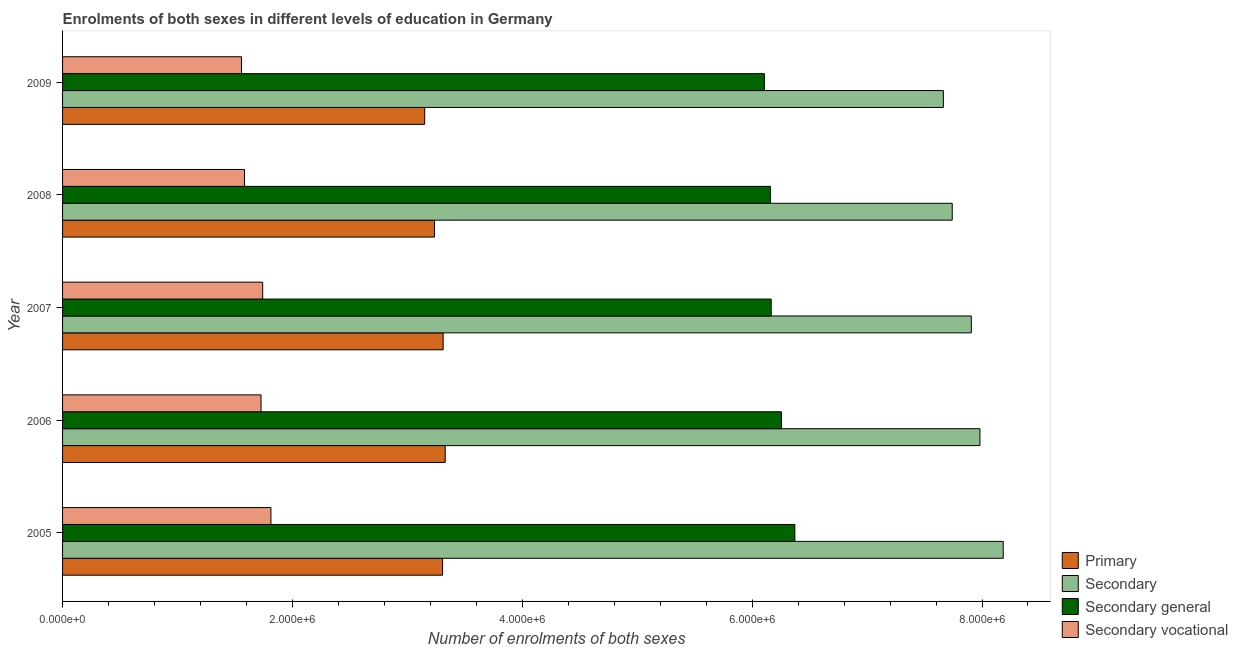Are the number of bars per tick equal to the number of legend labels?
Offer a terse response. Yes. How many bars are there on the 5th tick from the bottom?
Make the answer very short. 4. What is the label of the 5th group of bars from the top?
Make the answer very short. 2005. What is the number of enrolments in primary education in 2008?
Give a very brief answer. 3.24e+06. Across all years, what is the maximum number of enrolments in secondary education?
Your response must be concise. 8.18e+06. Across all years, what is the minimum number of enrolments in secondary vocational education?
Your answer should be very brief. 1.56e+06. What is the total number of enrolments in secondary education in the graph?
Your answer should be compact. 3.95e+07. What is the difference between the number of enrolments in primary education in 2008 and that in 2009?
Provide a succinct answer. 8.53e+04. What is the difference between the number of enrolments in secondary general education in 2007 and the number of enrolments in secondary education in 2005?
Provide a succinct answer. -2.02e+06. What is the average number of enrolments in secondary education per year?
Offer a very short reply. 7.90e+06. In the year 2009, what is the difference between the number of enrolments in secondary education and number of enrolments in secondary vocational education?
Provide a succinct answer. 6.11e+06. In how many years, is the number of enrolments in primary education greater than 8000000 ?
Offer a terse response. 0. What is the difference between the highest and the second highest number of enrolments in primary education?
Provide a short and direct response. 1.81e+04. What is the difference between the highest and the lowest number of enrolments in secondary vocational education?
Give a very brief answer. 2.56e+05. In how many years, is the number of enrolments in secondary general education greater than the average number of enrolments in secondary general education taken over all years?
Offer a terse response. 2. Is the sum of the number of enrolments in secondary education in 2005 and 2008 greater than the maximum number of enrolments in secondary general education across all years?
Give a very brief answer. Yes. What does the 2nd bar from the top in 2008 represents?
Provide a succinct answer. Secondary general. What does the 2nd bar from the bottom in 2005 represents?
Offer a very short reply. Secondary. Are the values on the major ticks of X-axis written in scientific E-notation?
Make the answer very short. Yes. How many legend labels are there?
Offer a very short reply. 4. What is the title of the graph?
Provide a short and direct response. Enrolments of both sexes in different levels of education in Germany. What is the label or title of the X-axis?
Give a very brief answer. Number of enrolments of both sexes. What is the label or title of the Y-axis?
Provide a succinct answer. Year. What is the Number of enrolments of both sexes of Primary in 2005?
Make the answer very short. 3.31e+06. What is the Number of enrolments of both sexes in Secondary in 2005?
Make the answer very short. 8.18e+06. What is the Number of enrolments of both sexes of Secondary general in 2005?
Keep it short and to the point. 6.37e+06. What is the Number of enrolments of both sexes of Secondary vocational in 2005?
Give a very brief answer. 1.81e+06. What is the Number of enrolments of both sexes in Primary in 2006?
Your answer should be very brief. 3.33e+06. What is the Number of enrolments of both sexes in Secondary in 2006?
Your response must be concise. 7.98e+06. What is the Number of enrolments of both sexes of Secondary general in 2006?
Provide a succinct answer. 6.26e+06. What is the Number of enrolments of both sexes of Secondary vocational in 2006?
Your answer should be compact. 1.73e+06. What is the Number of enrolments of both sexes in Primary in 2007?
Offer a very short reply. 3.31e+06. What is the Number of enrolments of both sexes of Secondary in 2007?
Your answer should be very brief. 7.91e+06. What is the Number of enrolments of both sexes of Secondary general in 2007?
Provide a short and direct response. 6.17e+06. What is the Number of enrolments of both sexes in Secondary vocational in 2007?
Your answer should be very brief. 1.74e+06. What is the Number of enrolments of both sexes in Primary in 2008?
Give a very brief answer. 3.24e+06. What is the Number of enrolments of both sexes in Secondary in 2008?
Provide a short and direct response. 7.74e+06. What is the Number of enrolments of both sexes in Secondary general in 2008?
Offer a terse response. 6.16e+06. What is the Number of enrolments of both sexes in Secondary vocational in 2008?
Your answer should be very brief. 1.58e+06. What is the Number of enrolments of both sexes in Primary in 2009?
Give a very brief answer. 3.15e+06. What is the Number of enrolments of both sexes in Secondary in 2009?
Your answer should be compact. 7.66e+06. What is the Number of enrolments of both sexes in Secondary general in 2009?
Keep it short and to the point. 6.11e+06. What is the Number of enrolments of both sexes of Secondary vocational in 2009?
Make the answer very short. 1.56e+06. Across all years, what is the maximum Number of enrolments of both sexes in Primary?
Provide a short and direct response. 3.33e+06. Across all years, what is the maximum Number of enrolments of both sexes of Secondary?
Ensure brevity in your answer.  8.18e+06. Across all years, what is the maximum Number of enrolments of both sexes of Secondary general?
Your answer should be compact. 6.37e+06. Across all years, what is the maximum Number of enrolments of both sexes of Secondary vocational?
Make the answer very short. 1.81e+06. Across all years, what is the minimum Number of enrolments of both sexes of Primary?
Offer a very short reply. 3.15e+06. Across all years, what is the minimum Number of enrolments of both sexes in Secondary?
Ensure brevity in your answer.  7.66e+06. Across all years, what is the minimum Number of enrolments of both sexes of Secondary general?
Your response must be concise. 6.11e+06. Across all years, what is the minimum Number of enrolments of both sexes in Secondary vocational?
Make the answer very short. 1.56e+06. What is the total Number of enrolments of both sexes in Primary in the graph?
Offer a terse response. 1.63e+07. What is the total Number of enrolments of both sexes of Secondary in the graph?
Your response must be concise. 3.95e+07. What is the total Number of enrolments of both sexes in Secondary general in the graph?
Your answer should be very brief. 3.11e+07. What is the total Number of enrolments of both sexes of Secondary vocational in the graph?
Keep it short and to the point. 8.42e+06. What is the difference between the Number of enrolments of both sexes of Primary in 2005 and that in 2006?
Make the answer very short. -2.32e+04. What is the difference between the Number of enrolments of both sexes in Secondary in 2005 and that in 2006?
Offer a very short reply. 2.03e+05. What is the difference between the Number of enrolments of both sexes in Secondary general in 2005 and that in 2006?
Offer a terse response. 1.16e+05. What is the difference between the Number of enrolments of both sexes in Secondary vocational in 2005 and that in 2006?
Provide a short and direct response. 8.63e+04. What is the difference between the Number of enrolments of both sexes in Primary in 2005 and that in 2007?
Your answer should be very brief. -5149. What is the difference between the Number of enrolments of both sexes in Secondary in 2005 and that in 2007?
Provide a short and direct response. 2.77e+05. What is the difference between the Number of enrolments of both sexes in Secondary general in 2005 and that in 2007?
Keep it short and to the point. 2.06e+05. What is the difference between the Number of enrolments of both sexes of Secondary vocational in 2005 and that in 2007?
Offer a very short reply. 7.17e+04. What is the difference between the Number of enrolments of both sexes of Primary in 2005 and that in 2008?
Offer a very short reply. 7.00e+04. What is the difference between the Number of enrolments of both sexes in Secondary in 2005 and that in 2008?
Offer a very short reply. 4.44e+05. What is the difference between the Number of enrolments of both sexes of Secondary general in 2005 and that in 2008?
Ensure brevity in your answer.  2.13e+05. What is the difference between the Number of enrolments of both sexes in Secondary vocational in 2005 and that in 2008?
Provide a short and direct response. 2.30e+05. What is the difference between the Number of enrolments of both sexes of Primary in 2005 and that in 2009?
Provide a short and direct response. 1.55e+05. What is the difference between the Number of enrolments of both sexes in Secondary in 2005 and that in 2009?
Ensure brevity in your answer.  5.21e+05. What is the difference between the Number of enrolments of both sexes of Secondary general in 2005 and that in 2009?
Your answer should be very brief. 2.65e+05. What is the difference between the Number of enrolments of both sexes of Secondary vocational in 2005 and that in 2009?
Your response must be concise. 2.56e+05. What is the difference between the Number of enrolments of both sexes in Primary in 2006 and that in 2007?
Keep it short and to the point. 1.81e+04. What is the difference between the Number of enrolments of both sexes of Secondary in 2006 and that in 2007?
Your answer should be compact. 7.47e+04. What is the difference between the Number of enrolments of both sexes in Secondary general in 2006 and that in 2007?
Provide a short and direct response. 8.93e+04. What is the difference between the Number of enrolments of both sexes of Secondary vocational in 2006 and that in 2007?
Your answer should be compact. -1.46e+04. What is the difference between the Number of enrolments of both sexes of Primary in 2006 and that in 2008?
Provide a succinct answer. 9.32e+04. What is the difference between the Number of enrolments of both sexes of Secondary in 2006 and that in 2008?
Provide a succinct answer. 2.41e+05. What is the difference between the Number of enrolments of both sexes in Secondary general in 2006 and that in 2008?
Provide a short and direct response. 9.69e+04. What is the difference between the Number of enrolments of both sexes in Secondary vocational in 2006 and that in 2008?
Keep it short and to the point. 1.44e+05. What is the difference between the Number of enrolments of both sexes of Primary in 2006 and that in 2009?
Keep it short and to the point. 1.79e+05. What is the difference between the Number of enrolments of both sexes of Secondary in 2006 and that in 2009?
Offer a terse response. 3.18e+05. What is the difference between the Number of enrolments of both sexes of Secondary general in 2006 and that in 2009?
Your answer should be compact. 1.49e+05. What is the difference between the Number of enrolments of both sexes in Secondary vocational in 2006 and that in 2009?
Offer a very short reply. 1.70e+05. What is the difference between the Number of enrolments of both sexes in Primary in 2007 and that in 2008?
Offer a terse response. 7.51e+04. What is the difference between the Number of enrolments of both sexes of Secondary in 2007 and that in 2008?
Provide a short and direct response. 1.66e+05. What is the difference between the Number of enrolments of both sexes in Secondary general in 2007 and that in 2008?
Provide a succinct answer. 7606. What is the difference between the Number of enrolments of both sexes of Secondary vocational in 2007 and that in 2008?
Provide a short and direct response. 1.59e+05. What is the difference between the Number of enrolments of both sexes of Primary in 2007 and that in 2009?
Give a very brief answer. 1.60e+05. What is the difference between the Number of enrolments of both sexes of Secondary in 2007 and that in 2009?
Give a very brief answer. 2.43e+05. What is the difference between the Number of enrolments of both sexes in Secondary general in 2007 and that in 2009?
Give a very brief answer. 5.93e+04. What is the difference between the Number of enrolments of both sexes of Secondary vocational in 2007 and that in 2009?
Keep it short and to the point. 1.84e+05. What is the difference between the Number of enrolments of both sexes of Primary in 2008 and that in 2009?
Your answer should be compact. 8.53e+04. What is the difference between the Number of enrolments of both sexes of Secondary in 2008 and that in 2009?
Provide a short and direct response. 7.72e+04. What is the difference between the Number of enrolments of both sexes of Secondary general in 2008 and that in 2009?
Provide a succinct answer. 5.17e+04. What is the difference between the Number of enrolments of both sexes of Secondary vocational in 2008 and that in 2009?
Provide a short and direct response. 2.55e+04. What is the difference between the Number of enrolments of both sexes of Primary in 2005 and the Number of enrolments of both sexes of Secondary in 2006?
Your response must be concise. -4.68e+06. What is the difference between the Number of enrolments of both sexes of Primary in 2005 and the Number of enrolments of both sexes of Secondary general in 2006?
Keep it short and to the point. -2.95e+06. What is the difference between the Number of enrolments of both sexes of Primary in 2005 and the Number of enrolments of both sexes of Secondary vocational in 2006?
Ensure brevity in your answer.  1.58e+06. What is the difference between the Number of enrolments of both sexes in Secondary in 2005 and the Number of enrolments of both sexes in Secondary general in 2006?
Provide a short and direct response. 1.93e+06. What is the difference between the Number of enrolments of both sexes in Secondary in 2005 and the Number of enrolments of both sexes in Secondary vocational in 2006?
Ensure brevity in your answer.  6.46e+06. What is the difference between the Number of enrolments of both sexes of Secondary general in 2005 and the Number of enrolments of both sexes of Secondary vocational in 2006?
Your response must be concise. 4.64e+06. What is the difference between the Number of enrolments of both sexes in Primary in 2005 and the Number of enrolments of both sexes in Secondary in 2007?
Offer a very short reply. -4.60e+06. What is the difference between the Number of enrolments of both sexes in Primary in 2005 and the Number of enrolments of both sexes in Secondary general in 2007?
Give a very brief answer. -2.86e+06. What is the difference between the Number of enrolments of both sexes in Primary in 2005 and the Number of enrolments of both sexes in Secondary vocational in 2007?
Provide a succinct answer. 1.56e+06. What is the difference between the Number of enrolments of both sexes of Secondary in 2005 and the Number of enrolments of both sexes of Secondary general in 2007?
Make the answer very short. 2.02e+06. What is the difference between the Number of enrolments of both sexes of Secondary in 2005 and the Number of enrolments of both sexes of Secondary vocational in 2007?
Your response must be concise. 6.44e+06. What is the difference between the Number of enrolments of both sexes of Secondary general in 2005 and the Number of enrolments of both sexes of Secondary vocational in 2007?
Your response must be concise. 4.63e+06. What is the difference between the Number of enrolments of both sexes in Primary in 2005 and the Number of enrolments of both sexes in Secondary in 2008?
Keep it short and to the point. -4.43e+06. What is the difference between the Number of enrolments of both sexes of Primary in 2005 and the Number of enrolments of both sexes of Secondary general in 2008?
Offer a terse response. -2.85e+06. What is the difference between the Number of enrolments of both sexes in Primary in 2005 and the Number of enrolments of both sexes in Secondary vocational in 2008?
Your response must be concise. 1.72e+06. What is the difference between the Number of enrolments of both sexes of Secondary in 2005 and the Number of enrolments of both sexes of Secondary general in 2008?
Give a very brief answer. 2.03e+06. What is the difference between the Number of enrolments of both sexes of Secondary in 2005 and the Number of enrolments of both sexes of Secondary vocational in 2008?
Your answer should be very brief. 6.60e+06. What is the difference between the Number of enrolments of both sexes in Secondary general in 2005 and the Number of enrolments of both sexes in Secondary vocational in 2008?
Make the answer very short. 4.79e+06. What is the difference between the Number of enrolments of both sexes in Primary in 2005 and the Number of enrolments of both sexes in Secondary in 2009?
Ensure brevity in your answer.  -4.36e+06. What is the difference between the Number of enrolments of both sexes of Primary in 2005 and the Number of enrolments of both sexes of Secondary general in 2009?
Offer a terse response. -2.80e+06. What is the difference between the Number of enrolments of both sexes of Primary in 2005 and the Number of enrolments of both sexes of Secondary vocational in 2009?
Make the answer very short. 1.75e+06. What is the difference between the Number of enrolments of both sexes of Secondary in 2005 and the Number of enrolments of both sexes of Secondary general in 2009?
Your answer should be compact. 2.08e+06. What is the difference between the Number of enrolments of both sexes of Secondary in 2005 and the Number of enrolments of both sexes of Secondary vocational in 2009?
Your answer should be very brief. 6.63e+06. What is the difference between the Number of enrolments of both sexes in Secondary general in 2005 and the Number of enrolments of both sexes in Secondary vocational in 2009?
Provide a short and direct response. 4.81e+06. What is the difference between the Number of enrolments of both sexes in Primary in 2006 and the Number of enrolments of both sexes in Secondary in 2007?
Give a very brief answer. -4.58e+06. What is the difference between the Number of enrolments of both sexes of Primary in 2006 and the Number of enrolments of both sexes of Secondary general in 2007?
Keep it short and to the point. -2.84e+06. What is the difference between the Number of enrolments of both sexes of Primary in 2006 and the Number of enrolments of both sexes of Secondary vocational in 2007?
Your answer should be compact. 1.59e+06. What is the difference between the Number of enrolments of both sexes of Secondary in 2006 and the Number of enrolments of both sexes of Secondary general in 2007?
Provide a short and direct response. 1.82e+06. What is the difference between the Number of enrolments of both sexes in Secondary in 2006 and the Number of enrolments of both sexes in Secondary vocational in 2007?
Your response must be concise. 6.24e+06. What is the difference between the Number of enrolments of both sexes in Secondary general in 2006 and the Number of enrolments of both sexes in Secondary vocational in 2007?
Your answer should be compact. 4.51e+06. What is the difference between the Number of enrolments of both sexes of Primary in 2006 and the Number of enrolments of both sexes of Secondary in 2008?
Your response must be concise. -4.41e+06. What is the difference between the Number of enrolments of both sexes of Primary in 2006 and the Number of enrolments of both sexes of Secondary general in 2008?
Give a very brief answer. -2.83e+06. What is the difference between the Number of enrolments of both sexes of Primary in 2006 and the Number of enrolments of both sexes of Secondary vocational in 2008?
Offer a very short reply. 1.75e+06. What is the difference between the Number of enrolments of both sexes of Secondary in 2006 and the Number of enrolments of both sexes of Secondary general in 2008?
Give a very brief answer. 1.82e+06. What is the difference between the Number of enrolments of both sexes of Secondary in 2006 and the Number of enrolments of both sexes of Secondary vocational in 2008?
Provide a succinct answer. 6.40e+06. What is the difference between the Number of enrolments of both sexes of Secondary general in 2006 and the Number of enrolments of both sexes of Secondary vocational in 2008?
Give a very brief answer. 4.67e+06. What is the difference between the Number of enrolments of both sexes in Primary in 2006 and the Number of enrolments of both sexes in Secondary in 2009?
Keep it short and to the point. -4.33e+06. What is the difference between the Number of enrolments of both sexes of Primary in 2006 and the Number of enrolments of both sexes of Secondary general in 2009?
Make the answer very short. -2.78e+06. What is the difference between the Number of enrolments of both sexes in Primary in 2006 and the Number of enrolments of both sexes in Secondary vocational in 2009?
Keep it short and to the point. 1.77e+06. What is the difference between the Number of enrolments of both sexes in Secondary in 2006 and the Number of enrolments of both sexes in Secondary general in 2009?
Your response must be concise. 1.88e+06. What is the difference between the Number of enrolments of both sexes of Secondary in 2006 and the Number of enrolments of both sexes of Secondary vocational in 2009?
Offer a terse response. 6.42e+06. What is the difference between the Number of enrolments of both sexes of Secondary general in 2006 and the Number of enrolments of both sexes of Secondary vocational in 2009?
Your response must be concise. 4.70e+06. What is the difference between the Number of enrolments of both sexes of Primary in 2007 and the Number of enrolments of both sexes of Secondary in 2008?
Ensure brevity in your answer.  -4.43e+06. What is the difference between the Number of enrolments of both sexes in Primary in 2007 and the Number of enrolments of both sexes in Secondary general in 2008?
Offer a very short reply. -2.85e+06. What is the difference between the Number of enrolments of both sexes in Primary in 2007 and the Number of enrolments of both sexes in Secondary vocational in 2008?
Provide a succinct answer. 1.73e+06. What is the difference between the Number of enrolments of both sexes of Secondary in 2007 and the Number of enrolments of both sexes of Secondary general in 2008?
Provide a succinct answer. 1.75e+06. What is the difference between the Number of enrolments of both sexes of Secondary in 2007 and the Number of enrolments of both sexes of Secondary vocational in 2008?
Offer a very short reply. 6.32e+06. What is the difference between the Number of enrolments of both sexes of Secondary general in 2007 and the Number of enrolments of both sexes of Secondary vocational in 2008?
Offer a very short reply. 4.58e+06. What is the difference between the Number of enrolments of both sexes in Primary in 2007 and the Number of enrolments of both sexes in Secondary in 2009?
Give a very brief answer. -4.35e+06. What is the difference between the Number of enrolments of both sexes in Primary in 2007 and the Number of enrolments of both sexes in Secondary general in 2009?
Offer a very short reply. -2.80e+06. What is the difference between the Number of enrolments of both sexes in Primary in 2007 and the Number of enrolments of both sexes in Secondary vocational in 2009?
Provide a short and direct response. 1.75e+06. What is the difference between the Number of enrolments of both sexes of Secondary in 2007 and the Number of enrolments of both sexes of Secondary general in 2009?
Offer a terse response. 1.80e+06. What is the difference between the Number of enrolments of both sexes of Secondary in 2007 and the Number of enrolments of both sexes of Secondary vocational in 2009?
Make the answer very short. 6.35e+06. What is the difference between the Number of enrolments of both sexes in Secondary general in 2007 and the Number of enrolments of both sexes in Secondary vocational in 2009?
Make the answer very short. 4.61e+06. What is the difference between the Number of enrolments of both sexes of Primary in 2008 and the Number of enrolments of both sexes of Secondary in 2009?
Give a very brief answer. -4.43e+06. What is the difference between the Number of enrolments of both sexes in Primary in 2008 and the Number of enrolments of both sexes in Secondary general in 2009?
Your answer should be very brief. -2.87e+06. What is the difference between the Number of enrolments of both sexes in Primary in 2008 and the Number of enrolments of both sexes in Secondary vocational in 2009?
Your response must be concise. 1.68e+06. What is the difference between the Number of enrolments of both sexes in Secondary in 2008 and the Number of enrolments of both sexes in Secondary general in 2009?
Provide a short and direct response. 1.63e+06. What is the difference between the Number of enrolments of both sexes in Secondary in 2008 and the Number of enrolments of both sexes in Secondary vocational in 2009?
Offer a very short reply. 6.18e+06. What is the difference between the Number of enrolments of both sexes in Secondary general in 2008 and the Number of enrolments of both sexes in Secondary vocational in 2009?
Keep it short and to the point. 4.60e+06. What is the average Number of enrolments of both sexes in Primary per year?
Provide a succinct answer. 3.27e+06. What is the average Number of enrolments of both sexes of Secondary per year?
Offer a terse response. 7.90e+06. What is the average Number of enrolments of both sexes in Secondary general per year?
Keep it short and to the point. 6.21e+06. What is the average Number of enrolments of both sexes in Secondary vocational per year?
Your answer should be very brief. 1.68e+06. In the year 2005, what is the difference between the Number of enrolments of both sexes of Primary and Number of enrolments of both sexes of Secondary?
Offer a very short reply. -4.88e+06. In the year 2005, what is the difference between the Number of enrolments of both sexes in Primary and Number of enrolments of both sexes in Secondary general?
Provide a short and direct response. -3.07e+06. In the year 2005, what is the difference between the Number of enrolments of both sexes of Primary and Number of enrolments of both sexes of Secondary vocational?
Provide a short and direct response. 1.49e+06. In the year 2005, what is the difference between the Number of enrolments of both sexes of Secondary and Number of enrolments of both sexes of Secondary general?
Offer a very short reply. 1.81e+06. In the year 2005, what is the difference between the Number of enrolments of both sexes in Secondary and Number of enrolments of both sexes in Secondary vocational?
Your response must be concise. 6.37e+06. In the year 2005, what is the difference between the Number of enrolments of both sexes of Secondary general and Number of enrolments of both sexes of Secondary vocational?
Keep it short and to the point. 4.56e+06. In the year 2006, what is the difference between the Number of enrolments of both sexes of Primary and Number of enrolments of both sexes of Secondary?
Provide a short and direct response. -4.65e+06. In the year 2006, what is the difference between the Number of enrolments of both sexes in Primary and Number of enrolments of both sexes in Secondary general?
Ensure brevity in your answer.  -2.93e+06. In the year 2006, what is the difference between the Number of enrolments of both sexes in Primary and Number of enrolments of both sexes in Secondary vocational?
Offer a terse response. 1.60e+06. In the year 2006, what is the difference between the Number of enrolments of both sexes of Secondary and Number of enrolments of both sexes of Secondary general?
Give a very brief answer. 1.73e+06. In the year 2006, what is the difference between the Number of enrolments of both sexes of Secondary and Number of enrolments of both sexes of Secondary vocational?
Keep it short and to the point. 6.26e+06. In the year 2006, what is the difference between the Number of enrolments of both sexes of Secondary general and Number of enrolments of both sexes of Secondary vocational?
Give a very brief answer. 4.53e+06. In the year 2007, what is the difference between the Number of enrolments of both sexes in Primary and Number of enrolments of both sexes in Secondary?
Give a very brief answer. -4.60e+06. In the year 2007, what is the difference between the Number of enrolments of both sexes in Primary and Number of enrolments of both sexes in Secondary general?
Your response must be concise. -2.85e+06. In the year 2007, what is the difference between the Number of enrolments of both sexes of Primary and Number of enrolments of both sexes of Secondary vocational?
Provide a short and direct response. 1.57e+06. In the year 2007, what is the difference between the Number of enrolments of both sexes in Secondary and Number of enrolments of both sexes in Secondary general?
Your response must be concise. 1.74e+06. In the year 2007, what is the difference between the Number of enrolments of both sexes of Secondary and Number of enrolments of both sexes of Secondary vocational?
Offer a very short reply. 6.17e+06. In the year 2007, what is the difference between the Number of enrolments of both sexes of Secondary general and Number of enrolments of both sexes of Secondary vocational?
Your answer should be compact. 4.42e+06. In the year 2008, what is the difference between the Number of enrolments of both sexes in Primary and Number of enrolments of both sexes in Secondary?
Make the answer very short. -4.50e+06. In the year 2008, what is the difference between the Number of enrolments of both sexes of Primary and Number of enrolments of both sexes of Secondary general?
Keep it short and to the point. -2.92e+06. In the year 2008, what is the difference between the Number of enrolments of both sexes in Primary and Number of enrolments of both sexes in Secondary vocational?
Your answer should be very brief. 1.65e+06. In the year 2008, what is the difference between the Number of enrolments of both sexes of Secondary and Number of enrolments of both sexes of Secondary general?
Your response must be concise. 1.58e+06. In the year 2008, what is the difference between the Number of enrolments of both sexes of Secondary and Number of enrolments of both sexes of Secondary vocational?
Give a very brief answer. 6.16e+06. In the year 2008, what is the difference between the Number of enrolments of both sexes in Secondary general and Number of enrolments of both sexes in Secondary vocational?
Keep it short and to the point. 4.58e+06. In the year 2009, what is the difference between the Number of enrolments of both sexes of Primary and Number of enrolments of both sexes of Secondary?
Keep it short and to the point. -4.51e+06. In the year 2009, what is the difference between the Number of enrolments of both sexes in Primary and Number of enrolments of both sexes in Secondary general?
Provide a short and direct response. -2.96e+06. In the year 2009, what is the difference between the Number of enrolments of both sexes in Primary and Number of enrolments of both sexes in Secondary vocational?
Provide a succinct answer. 1.59e+06. In the year 2009, what is the difference between the Number of enrolments of both sexes in Secondary and Number of enrolments of both sexes in Secondary general?
Give a very brief answer. 1.56e+06. In the year 2009, what is the difference between the Number of enrolments of both sexes in Secondary and Number of enrolments of both sexes in Secondary vocational?
Your answer should be compact. 6.11e+06. In the year 2009, what is the difference between the Number of enrolments of both sexes in Secondary general and Number of enrolments of both sexes in Secondary vocational?
Ensure brevity in your answer.  4.55e+06. What is the ratio of the Number of enrolments of both sexes in Secondary in 2005 to that in 2006?
Provide a succinct answer. 1.03. What is the ratio of the Number of enrolments of both sexes of Secondary general in 2005 to that in 2006?
Give a very brief answer. 1.02. What is the ratio of the Number of enrolments of both sexes in Primary in 2005 to that in 2007?
Offer a terse response. 1. What is the ratio of the Number of enrolments of both sexes of Secondary in 2005 to that in 2007?
Make the answer very short. 1.04. What is the ratio of the Number of enrolments of both sexes of Secondary general in 2005 to that in 2007?
Your answer should be very brief. 1.03. What is the ratio of the Number of enrolments of both sexes of Secondary vocational in 2005 to that in 2007?
Your answer should be very brief. 1.04. What is the ratio of the Number of enrolments of both sexes of Primary in 2005 to that in 2008?
Your response must be concise. 1.02. What is the ratio of the Number of enrolments of both sexes of Secondary in 2005 to that in 2008?
Your response must be concise. 1.06. What is the ratio of the Number of enrolments of both sexes in Secondary general in 2005 to that in 2008?
Your answer should be compact. 1.03. What is the ratio of the Number of enrolments of both sexes in Secondary vocational in 2005 to that in 2008?
Your answer should be compact. 1.15. What is the ratio of the Number of enrolments of both sexes of Primary in 2005 to that in 2009?
Your answer should be very brief. 1.05. What is the ratio of the Number of enrolments of both sexes of Secondary in 2005 to that in 2009?
Offer a terse response. 1.07. What is the ratio of the Number of enrolments of both sexes in Secondary general in 2005 to that in 2009?
Ensure brevity in your answer.  1.04. What is the ratio of the Number of enrolments of both sexes in Secondary vocational in 2005 to that in 2009?
Your answer should be compact. 1.16. What is the ratio of the Number of enrolments of both sexes of Primary in 2006 to that in 2007?
Your answer should be very brief. 1.01. What is the ratio of the Number of enrolments of both sexes of Secondary in 2006 to that in 2007?
Give a very brief answer. 1.01. What is the ratio of the Number of enrolments of both sexes of Secondary general in 2006 to that in 2007?
Give a very brief answer. 1.01. What is the ratio of the Number of enrolments of both sexes in Secondary vocational in 2006 to that in 2007?
Provide a succinct answer. 0.99. What is the ratio of the Number of enrolments of both sexes of Primary in 2006 to that in 2008?
Make the answer very short. 1.03. What is the ratio of the Number of enrolments of both sexes of Secondary in 2006 to that in 2008?
Offer a terse response. 1.03. What is the ratio of the Number of enrolments of both sexes in Secondary general in 2006 to that in 2008?
Your answer should be very brief. 1.02. What is the ratio of the Number of enrolments of both sexes of Secondary vocational in 2006 to that in 2008?
Make the answer very short. 1.09. What is the ratio of the Number of enrolments of both sexes in Primary in 2006 to that in 2009?
Make the answer very short. 1.06. What is the ratio of the Number of enrolments of both sexes of Secondary in 2006 to that in 2009?
Your response must be concise. 1.04. What is the ratio of the Number of enrolments of both sexes of Secondary general in 2006 to that in 2009?
Provide a succinct answer. 1.02. What is the ratio of the Number of enrolments of both sexes in Secondary vocational in 2006 to that in 2009?
Keep it short and to the point. 1.11. What is the ratio of the Number of enrolments of both sexes of Primary in 2007 to that in 2008?
Offer a very short reply. 1.02. What is the ratio of the Number of enrolments of both sexes in Secondary in 2007 to that in 2008?
Offer a terse response. 1.02. What is the ratio of the Number of enrolments of both sexes in Secondary vocational in 2007 to that in 2008?
Your response must be concise. 1.1. What is the ratio of the Number of enrolments of both sexes of Primary in 2007 to that in 2009?
Ensure brevity in your answer.  1.05. What is the ratio of the Number of enrolments of both sexes in Secondary in 2007 to that in 2009?
Make the answer very short. 1.03. What is the ratio of the Number of enrolments of both sexes of Secondary general in 2007 to that in 2009?
Offer a terse response. 1.01. What is the ratio of the Number of enrolments of both sexes in Secondary vocational in 2007 to that in 2009?
Provide a succinct answer. 1.12. What is the ratio of the Number of enrolments of both sexes of Primary in 2008 to that in 2009?
Offer a very short reply. 1.03. What is the ratio of the Number of enrolments of both sexes of Secondary general in 2008 to that in 2009?
Offer a very short reply. 1.01. What is the ratio of the Number of enrolments of both sexes in Secondary vocational in 2008 to that in 2009?
Make the answer very short. 1.02. What is the difference between the highest and the second highest Number of enrolments of both sexes of Primary?
Your response must be concise. 1.81e+04. What is the difference between the highest and the second highest Number of enrolments of both sexes in Secondary?
Your answer should be very brief. 2.03e+05. What is the difference between the highest and the second highest Number of enrolments of both sexes of Secondary general?
Offer a terse response. 1.16e+05. What is the difference between the highest and the second highest Number of enrolments of both sexes of Secondary vocational?
Keep it short and to the point. 7.17e+04. What is the difference between the highest and the lowest Number of enrolments of both sexes in Primary?
Your answer should be very brief. 1.79e+05. What is the difference between the highest and the lowest Number of enrolments of both sexes of Secondary?
Give a very brief answer. 5.21e+05. What is the difference between the highest and the lowest Number of enrolments of both sexes in Secondary general?
Ensure brevity in your answer.  2.65e+05. What is the difference between the highest and the lowest Number of enrolments of both sexes in Secondary vocational?
Offer a very short reply. 2.56e+05. 